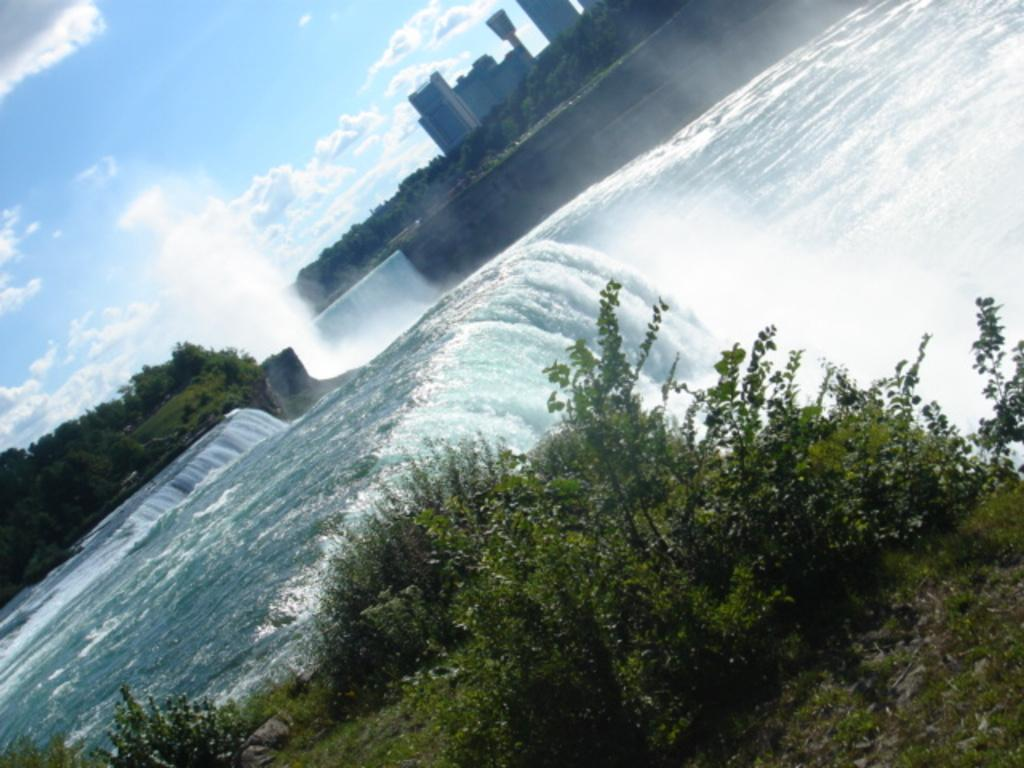What natural feature is present in the image? There is a waterfall in the image. What type of vegetation can be seen in the image? There are trees in the image. What man-made structures are visible in the image? There are buildings in the image. What colors are present in the sky in the image? The sky is blue and white in color. What type of ring can be seen on the waterfall in the image? There is no ring present on the waterfall in the image. What type of celery is growing near the waterfall in the image? There is no celery present in the image. 